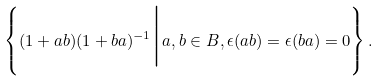<formula> <loc_0><loc_0><loc_500><loc_500>\left \{ ( 1 + a b ) ( 1 + b a ) ^ { - 1 } \Big { | } a , b \in B , \epsilon ( a b ) = \epsilon ( b a ) = 0 \right \} .</formula> 